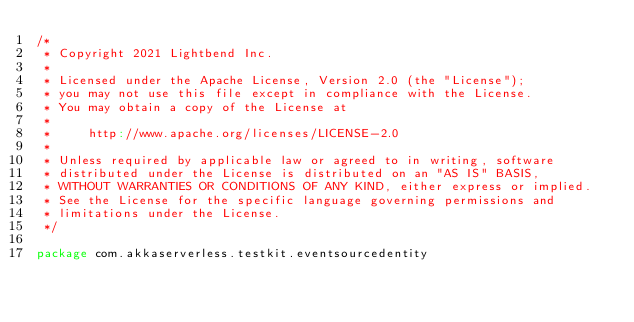Convert code to text. <code><loc_0><loc_0><loc_500><loc_500><_Scala_>/*
 * Copyright 2021 Lightbend Inc.
 *
 * Licensed under the Apache License, Version 2.0 (the "License");
 * you may not use this file except in compliance with the License.
 * You may obtain a copy of the License at
 *
 *     http://www.apache.org/licenses/LICENSE-2.0
 *
 * Unless required by applicable law or agreed to in writing, software
 * distributed under the License is distributed on an "AS IS" BASIS,
 * WITHOUT WARRANTIES OR CONDITIONS OF ANY KIND, either express or implied.
 * See the License for the specific language governing permissions and
 * limitations under the License.
 */

package com.akkaserverless.testkit.eventsourcedentity
</code> 